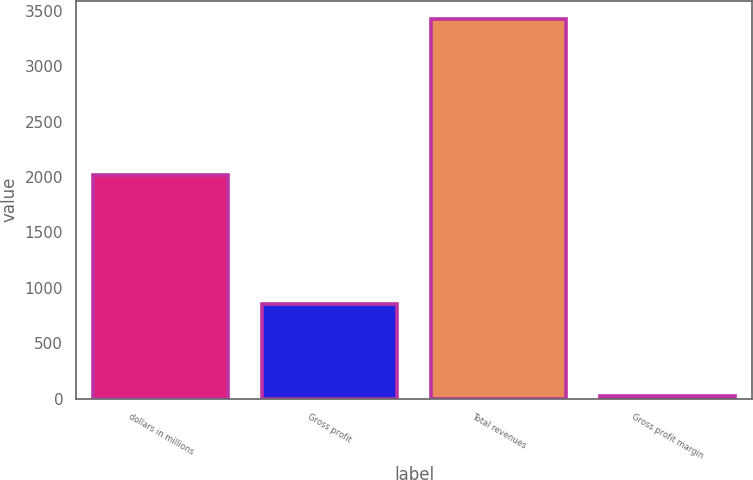Convert chart. <chart><loc_0><loc_0><loc_500><loc_500><bar_chart><fcel>dollars in millions<fcel>Gross profit<fcel>Total revenues<fcel>Gross profit margin<nl><fcel>2015<fcel>857.5<fcel>3422.2<fcel>25.1<nl></chart> 